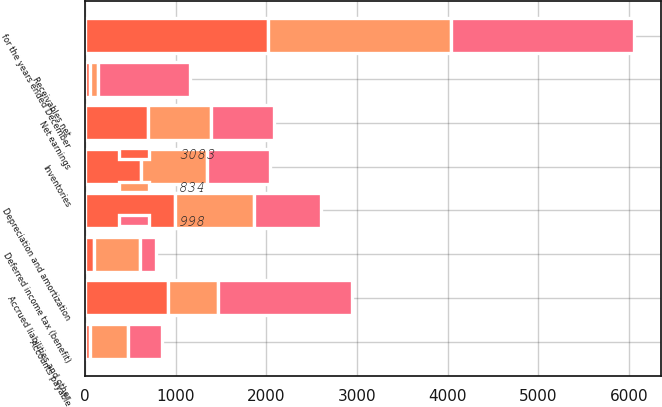Convert chart. <chart><loc_0><loc_0><loc_500><loc_500><stacked_bar_chart><ecel><fcel>for the years ended December<fcel>Net earnings<fcel>Depreciation and amortization<fcel>Deferred income tax (benefit)<fcel>Receivables net<fcel>Inventories<fcel>Accounts payable<fcel>Accrued liabilities and other<nl><fcel>3083<fcel>2018<fcel>695<fcel>989<fcel>100<fcel>53<fcel>613<fcel>51<fcel>910<nl><fcel>834<fcel>2017<fcel>695<fcel>875<fcel>501<fcel>92<fcel>730<fcel>425<fcel>554<nl><fcel>998<fcel>2016<fcel>695<fcel>743<fcel>182<fcel>1009<fcel>695<fcel>373<fcel>1477<nl></chart> 